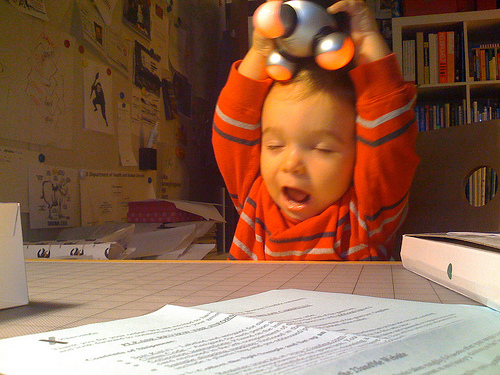<image>
Is there a baby under the toy? Yes. The baby is positioned underneath the toy, with the toy above it in the vertical space. Is the toy above the boy? Yes. The toy is positioned above the boy in the vertical space, higher up in the scene. Is the baby in front of the paper? Yes. The baby is positioned in front of the paper, appearing closer to the camera viewpoint. 